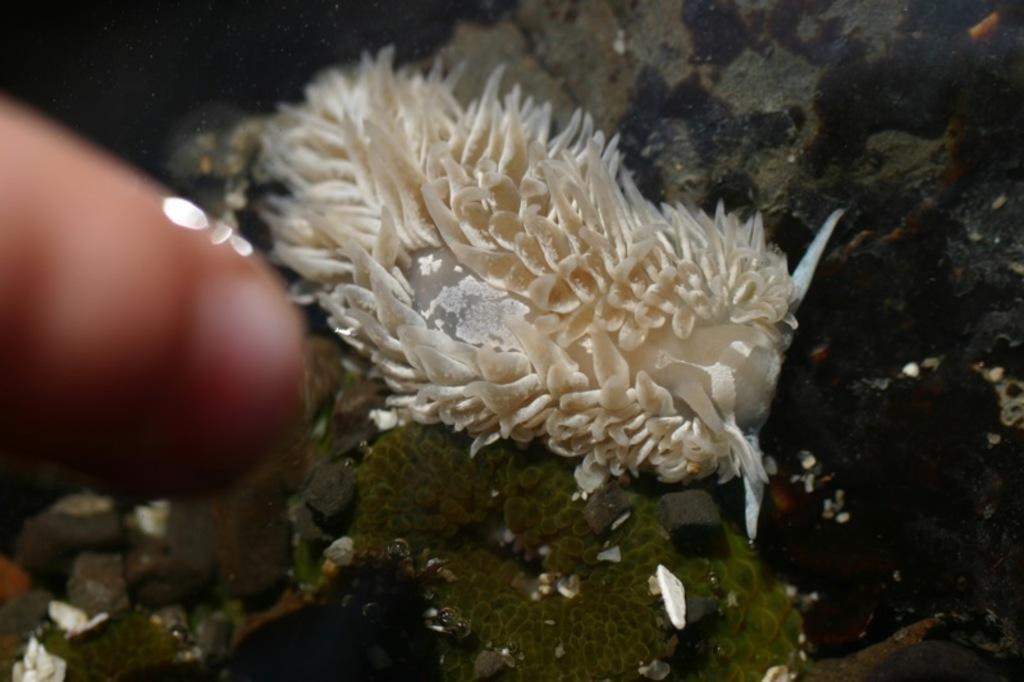In one or two sentences, can you explain what this image depicts? This picture is taken from inside the water. In the center of the image there is a water animal and we can see a finger of a person. At the bottom of the image there are stones. 